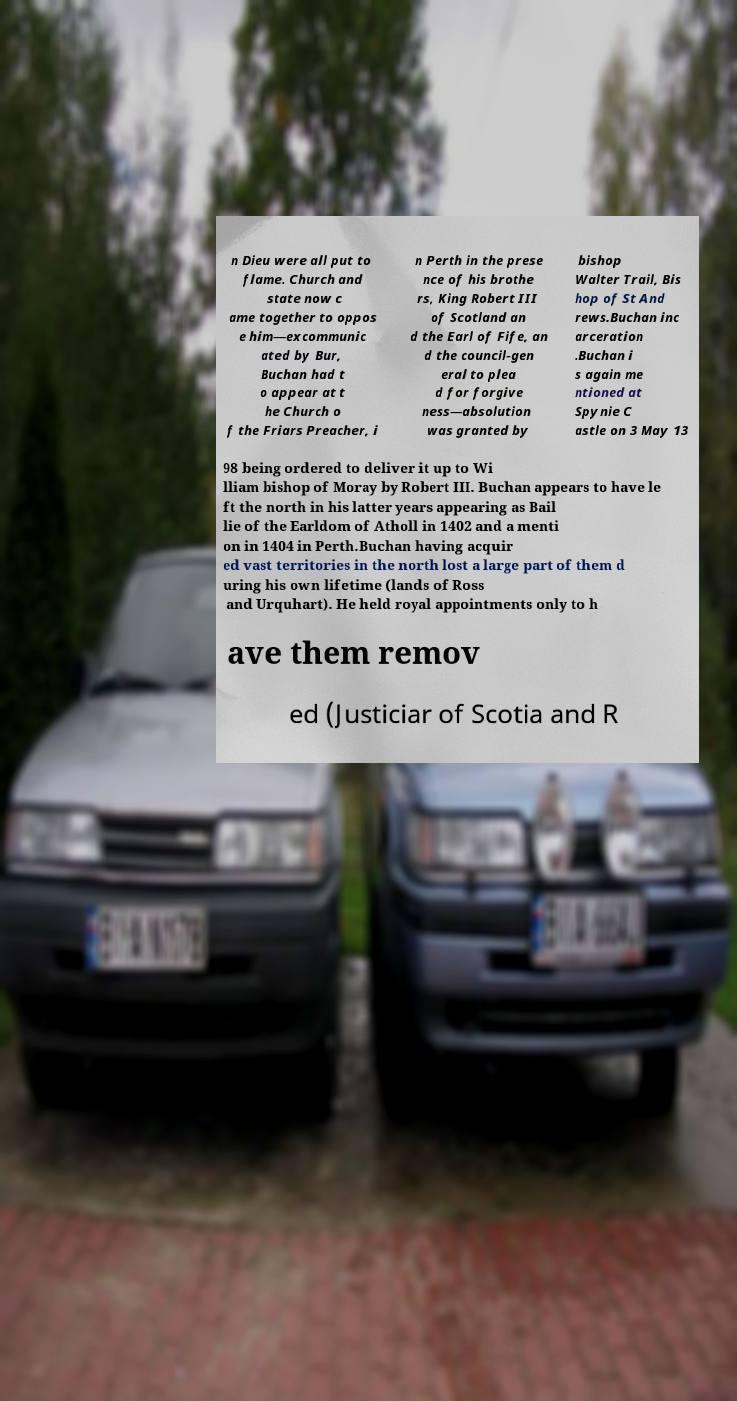Can you read and provide the text displayed in the image?This photo seems to have some interesting text. Can you extract and type it out for me? n Dieu were all put to flame. Church and state now c ame together to oppos e him—excommunic ated by Bur, Buchan had t o appear at t he Church o f the Friars Preacher, i n Perth in the prese nce of his brothe rs, King Robert III of Scotland an d the Earl of Fife, an d the council-gen eral to plea d for forgive ness—absolution was granted by bishop Walter Trail, Bis hop of St And rews.Buchan inc arceration .Buchan i s again me ntioned at Spynie C astle on 3 May 13 98 being ordered to deliver it up to Wi lliam bishop of Moray by Robert III. Buchan appears to have le ft the north in his latter years appearing as Bail lie of the Earldom of Atholl in 1402 and a menti on in 1404 in Perth.Buchan having acquir ed vast territories in the north lost a large part of them d uring his own lifetime (lands of Ross and Urquhart). He held royal appointments only to h ave them remov ed (Justiciar of Scotia and R 